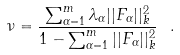<formula> <loc_0><loc_0><loc_500><loc_500>\nu = \frac { \sum _ { \alpha = 1 } ^ { m } \lambda _ { \alpha } | | F _ { \alpha } | | ^ { 2 } _ { k } } { 1 - \sum _ { \alpha = 1 } ^ { m } | | F _ { \alpha } | | ^ { 2 } _ { k } } \ .</formula> 